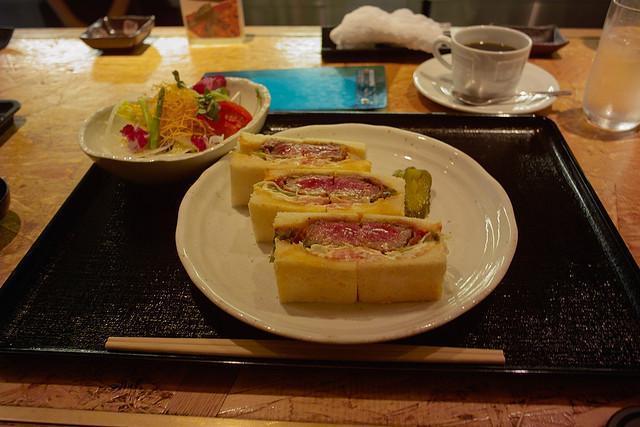How many bowls are there?
Give a very brief answer. 1. How many sandwiches are visible?
Give a very brief answer. 3. How many cups can you see?
Give a very brief answer. 2. How many people are visible to the left of the parked cars?
Give a very brief answer. 0. 